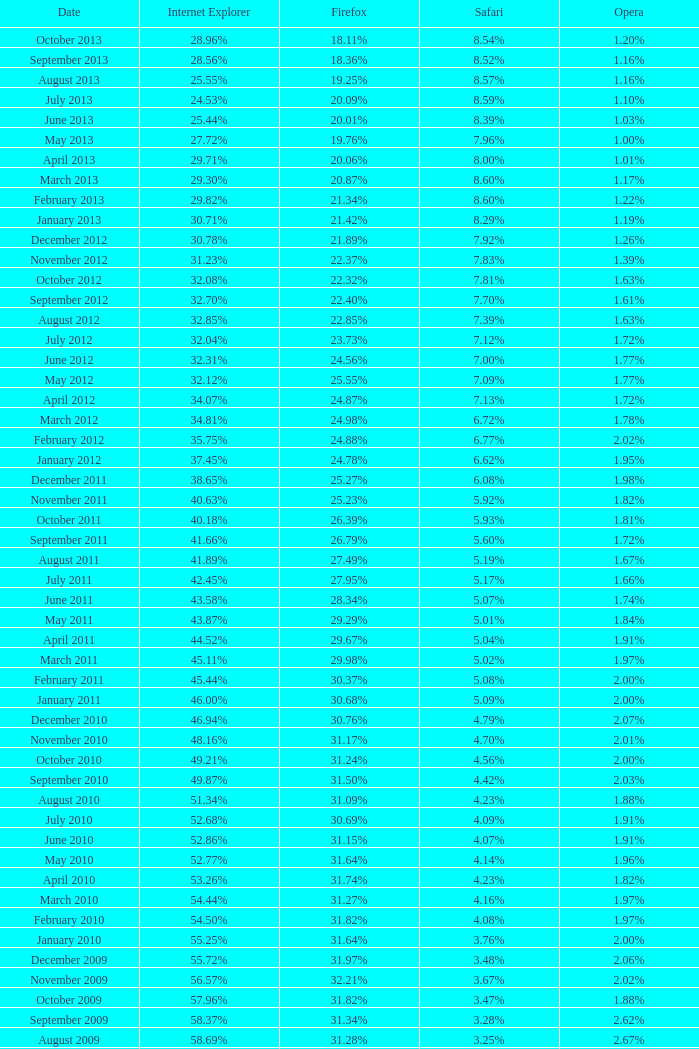What proportion of browsers utilized safari during the time when 3 4.16%. 